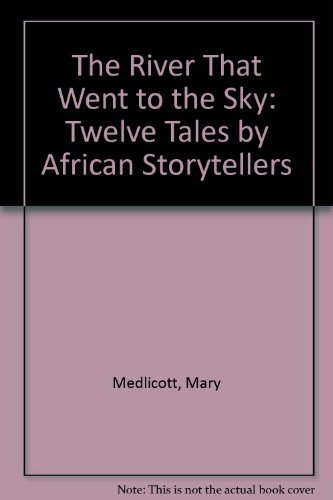What is the title of this book? The book is titled 'The River That Went to the Sky: Twelve Tales by African Storytellers,' which suggests enchanting narratives set in African settings. 